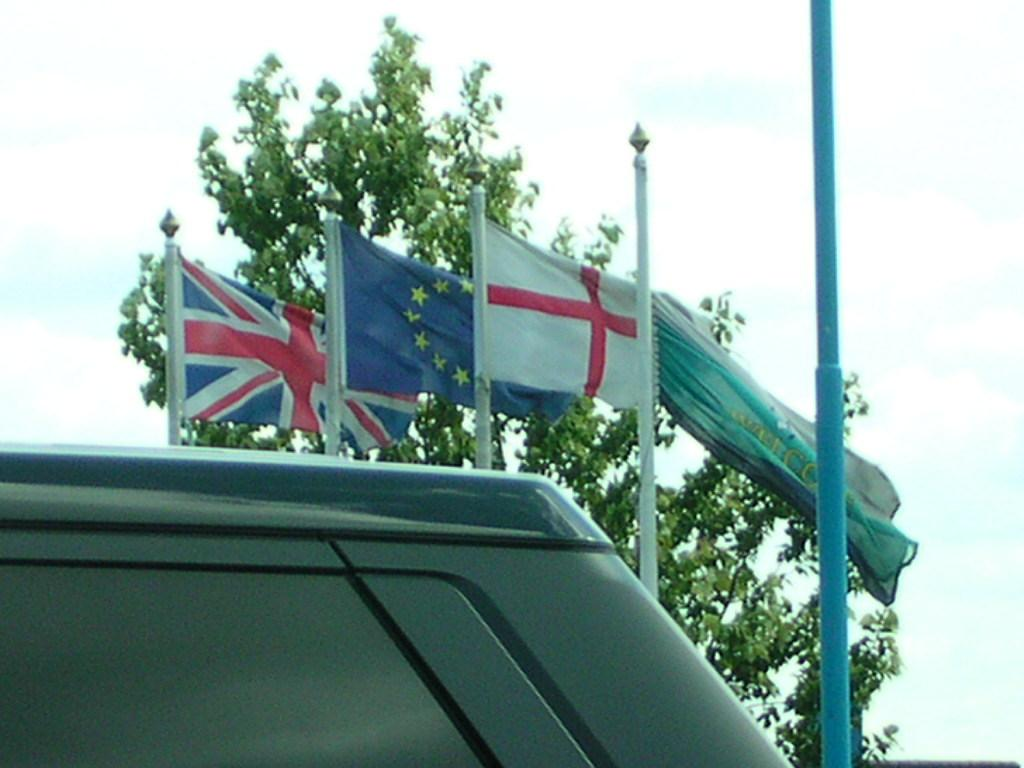What is the main subject in the front of the image? There is an object in the front of the image. What can be seen in the background of the image? There are flags and trees in the background of the image. What else is visible in the background of the image? The sky is visible in the background of the image. What type of animal is the carpenter's mother holding in the image? There is no animal or carpenter's mother present in the image. 